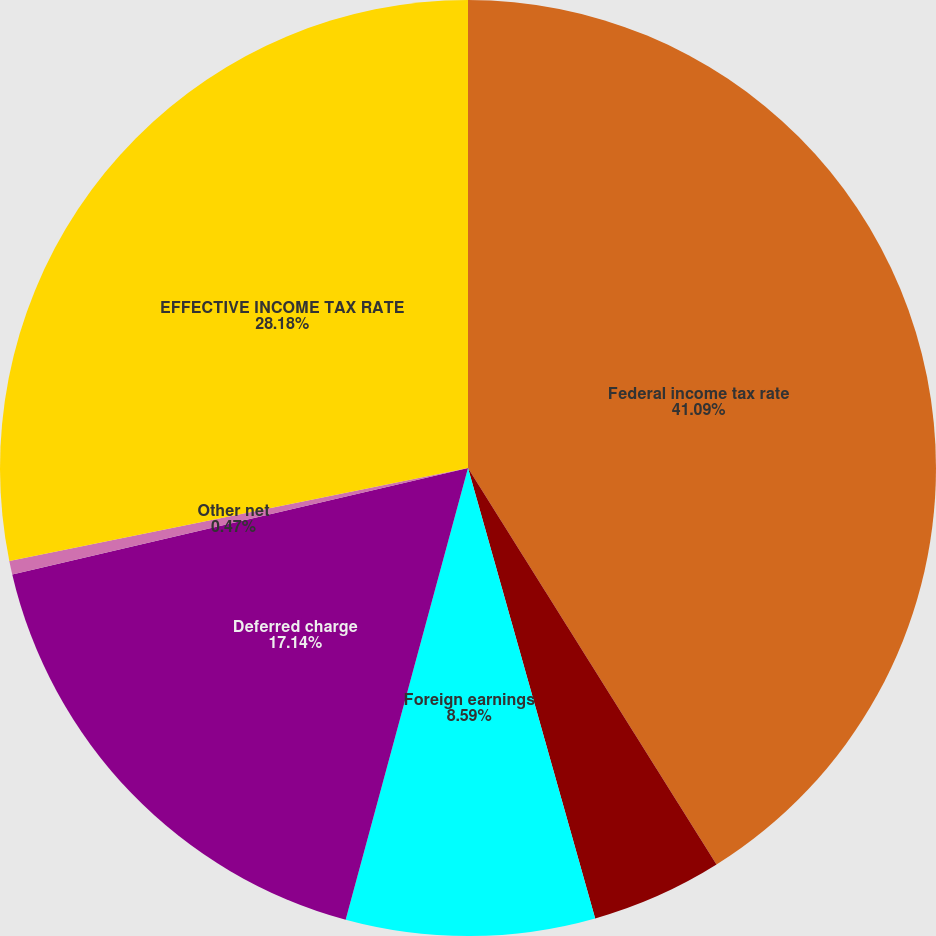Convert chart to OTSL. <chart><loc_0><loc_0><loc_500><loc_500><pie_chart><fcel>Federal income tax rate<fcel>State taxes net of federal<fcel>Foreign earnings<fcel>Deferred charge<fcel>Other net<fcel>EFFECTIVE INCOME TAX RATE<nl><fcel>41.09%<fcel>4.53%<fcel>8.59%<fcel>17.14%<fcel>0.47%<fcel>28.18%<nl></chart> 